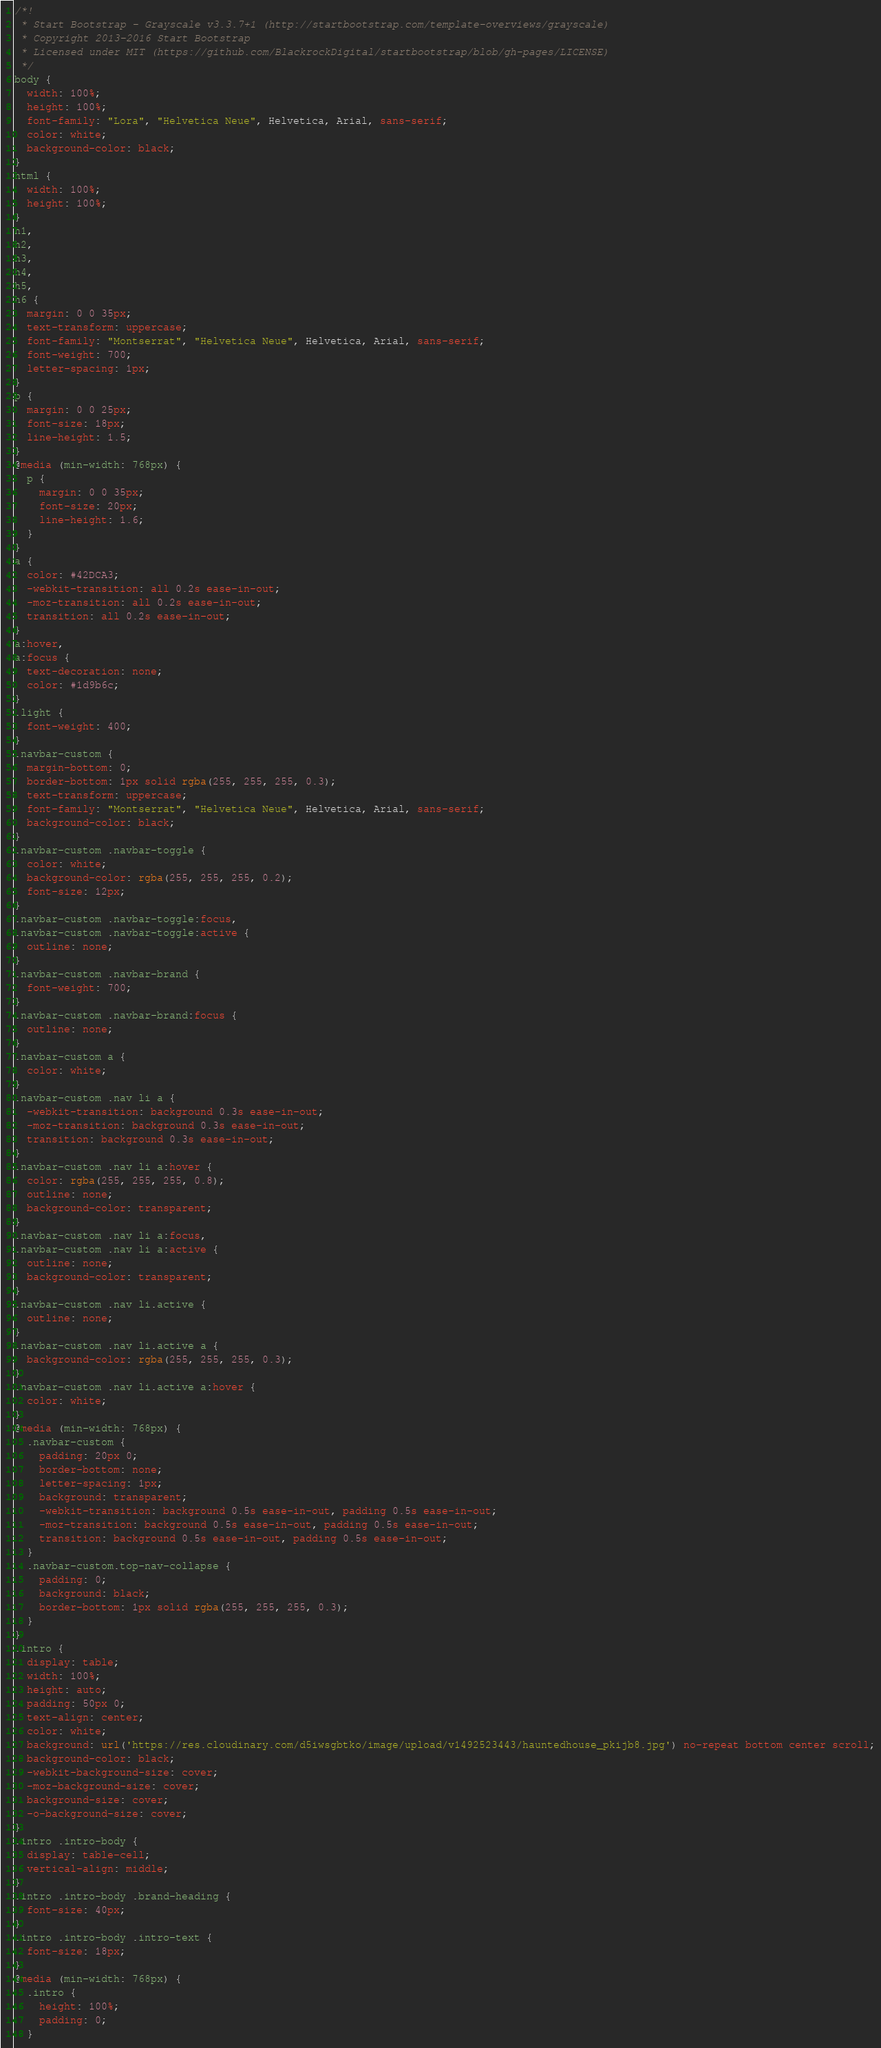<code> <loc_0><loc_0><loc_500><loc_500><_CSS_>/*!
 * Start Bootstrap - Grayscale v3.3.7+1 (http://startbootstrap.com/template-overviews/grayscale)
 * Copyright 2013-2016 Start Bootstrap
 * Licensed under MIT (https://github.com/BlackrockDigital/startbootstrap/blob/gh-pages/LICENSE)
 */
body {
  width: 100%;
  height: 100%;
  font-family: "Lora", "Helvetica Neue", Helvetica, Arial, sans-serif;
  color: white;
  background-color: black;
}
html {
  width: 100%;
  height: 100%;
}
h1,
h2,
h3,
h4,
h5,
h6 {
  margin: 0 0 35px;
  text-transform: uppercase;
  font-family: "Montserrat", "Helvetica Neue", Helvetica, Arial, sans-serif;
  font-weight: 700;
  letter-spacing: 1px;
}
p {
  margin: 0 0 25px;
  font-size: 18px;
  line-height: 1.5;
}
@media (min-width: 768px) {
  p {
    margin: 0 0 35px;
    font-size: 20px;
    line-height: 1.6;
  }
}
a {
  color: #42DCA3;
  -webkit-transition: all 0.2s ease-in-out;
  -moz-transition: all 0.2s ease-in-out;
  transition: all 0.2s ease-in-out;
}
a:hover,
a:focus {
  text-decoration: none;
  color: #1d9b6c;
}
.light {
  font-weight: 400;
}
.navbar-custom {
  margin-bottom: 0;
  border-bottom: 1px solid rgba(255, 255, 255, 0.3);
  text-transform: uppercase;
  font-family: "Montserrat", "Helvetica Neue", Helvetica, Arial, sans-serif;
  background-color: black;
}
.navbar-custom .navbar-toggle {
  color: white;
  background-color: rgba(255, 255, 255, 0.2);
  font-size: 12px;
}
.navbar-custom .navbar-toggle:focus,
.navbar-custom .navbar-toggle:active {
  outline: none;
}
.navbar-custom .navbar-brand {
  font-weight: 700;
}
.navbar-custom .navbar-brand:focus {
  outline: none;
}
.navbar-custom a {
  color: white;
}
.navbar-custom .nav li a {
  -webkit-transition: background 0.3s ease-in-out;
  -moz-transition: background 0.3s ease-in-out;
  transition: background 0.3s ease-in-out;
}
.navbar-custom .nav li a:hover {
  color: rgba(255, 255, 255, 0.8);
  outline: none;
  background-color: transparent;
}
.navbar-custom .nav li a:focus,
.navbar-custom .nav li a:active {
  outline: none;
  background-color: transparent;
}
.navbar-custom .nav li.active {
  outline: none;
}
.navbar-custom .nav li.active a {
  background-color: rgba(255, 255, 255, 0.3);
}
.navbar-custom .nav li.active a:hover {
  color: white;
}
@media (min-width: 768px) {
  .navbar-custom {
    padding: 20px 0;
    border-bottom: none;
    letter-spacing: 1px;
    background: transparent;
    -webkit-transition: background 0.5s ease-in-out, padding 0.5s ease-in-out;
    -moz-transition: background 0.5s ease-in-out, padding 0.5s ease-in-out;
    transition: background 0.5s ease-in-out, padding 0.5s ease-in-out;
  }
  .navbar-custom.top-nav-collapse {
    padding: 0;
    background: black;
    border-bottom: 1px solid rgba(255, 255, 255, 0.3);
  }
}
.intro {
  display: table;
  width: 100%;
  height: auto;
  padding: 50px 0;
  text-align: center;
  color: white;
  background: url('https://res.cloudinary.com/d5iwsgbtko/image/upload/v1492523443/hauntedhouse_pkijb8.jpg') no-repeat bottom center scroll;
  background-color: black;
  -webkit-background-size: cover;
  -moz-background-size: cover;
  background-size: cover;
  -o-background-size: cover;
}
.intro .intro-body {
  display: table-cell;
  vertical-align: middle;
}
.intro .intro-body .brand-heading {
  font-size: 40px;
}
.intro .intro-body .intro-text {
  font-size: 18px;
}
@media (min-width: 768px) {
  .intro {
    height: 100%;
    padding: 0;
  }</code> 